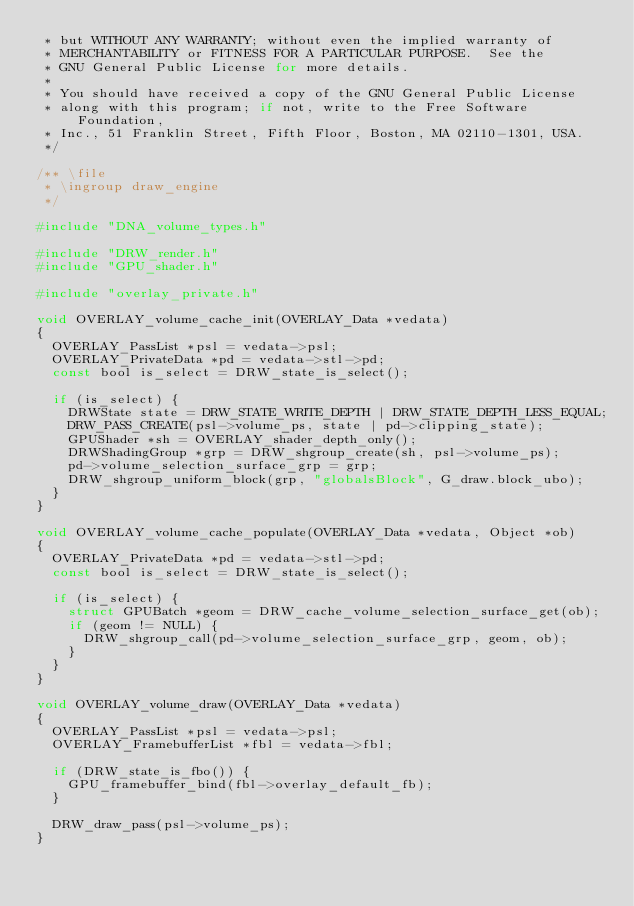<code> <loc_0><loc_0><loc_500><loc_500><_C_> * but WITHOUT ANY WARRANTY; without even the implied warranty of
 * MERCHANTABILITY or FITNESS FOR A PARTICULAR PURPOSE.  See the
 * GNU General Public License for more details.
 *
 * You should have received a copy of the GNU General Public License
 * along with this program; if not, write to the Free Software Foundation,
 * Inc., 51 Franklin Street, Fifth Floor, Boston, MA 02110-1301, USA.
 */

/** \file
 * \ingroup draw_engine
 */

#include "DNA_volume_types.h"

#include "DRW_render.h"
#include "GPU_shader.h"

#include "overlay_private.h"

void OVERLAY_volume_cache_init(OVERLAY_Data *vedata)
{
  OVERLAY_PassList *psl = vedata->psl;
  OVERLAY_PrivateData *pd = vedata->stl->pd;
  const bool is_select = DRW_state_is_select();

  if (is_select) {
    DRWState state = DRW_STATE_WRITE_DEPTH | DRW_STATE_DEPTH_LESS_EQUAL;
    DRW_PASS_CREATE(psl->volume_ps, state | pd->clipping_state);
    GPUShader *sh = OVERLAY_shader_depth_only();
    DRWShadingGroup *grp = DRW_shgroup_create(sh, psl->volume_ps);
    pd->volume_selection_surface_grp = grp;
    DRW_shgroup_uniform_block(grp, "globalsBlock", G_draw.block_ubo);
  }
}

void OVERLAY_volume_cache_populate(OVERLAY_Data *vedata, Object *ob)
{
  OVERLAY_PrivateData *pd = vedata->stl->pd;
  const bool is_select = DRW_state_is_select();

  if (is_select) {
    struct GPUBatch *geom = DRW_cache_volume_selection_surface_get(ob);
    if (geom != NULL) {
      DRW_shgroup_call(pd->volume_selection_surface_grp, geom, ob);
    }
  }
}

void OVERLAY_volume_draw(OVERLAY_Data *vedata)
{
  OVERLAY_PassList *psl = vedata->psl;
  OVERLAY_FramebufferList *fbl = vedata->fbl;

  if (DRW_state_is_fbo()) {
    GPU_framebuffer_bind(fbl->overlay_default_fb);
  }

  DRW_draw_pass(psl->volume_ps);
}
</code> 